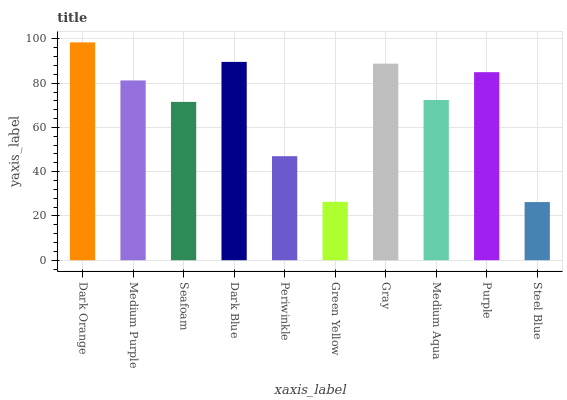Is Steel Blue the minimum?
Answer yes or no. Yes. Is Dark Orange the maximum?
Answer yes or no. Yes. Is Medium Purple the minimum?
Answer yes or no. No. Is Medium Purple the maximum?
Answer yes or no. No. Is Dark Orange greater than Medium Purple?
Answer yes or no. Yes. Is Medium Purple less than Dark Orange?
Answer yes or no. Yes. Is Medium Purple greater than Dark Orange?
Answer yes or no. No. Is Dark Orange less than Medium Purple?
Answer yes or no. No. Is Medium Purple the high median?
Answer yes or no. Yes. Is Medium Aqua the low median?
Answer yes or no. Yes. Is Periwinkle the high median?
Answer yes or no. No. Is Dark Orange the low median?
Answer yes or no. No. 